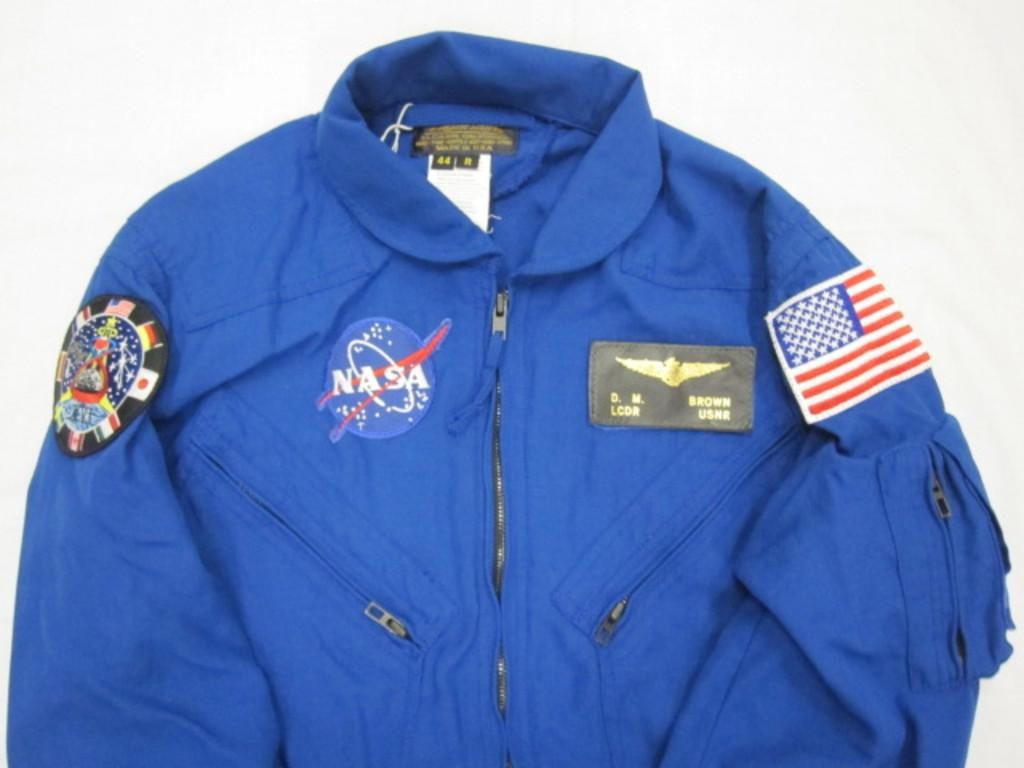Provide a one-sentence caption for the provided image. blue nasa flight suit that belongs to d.m. brown. 